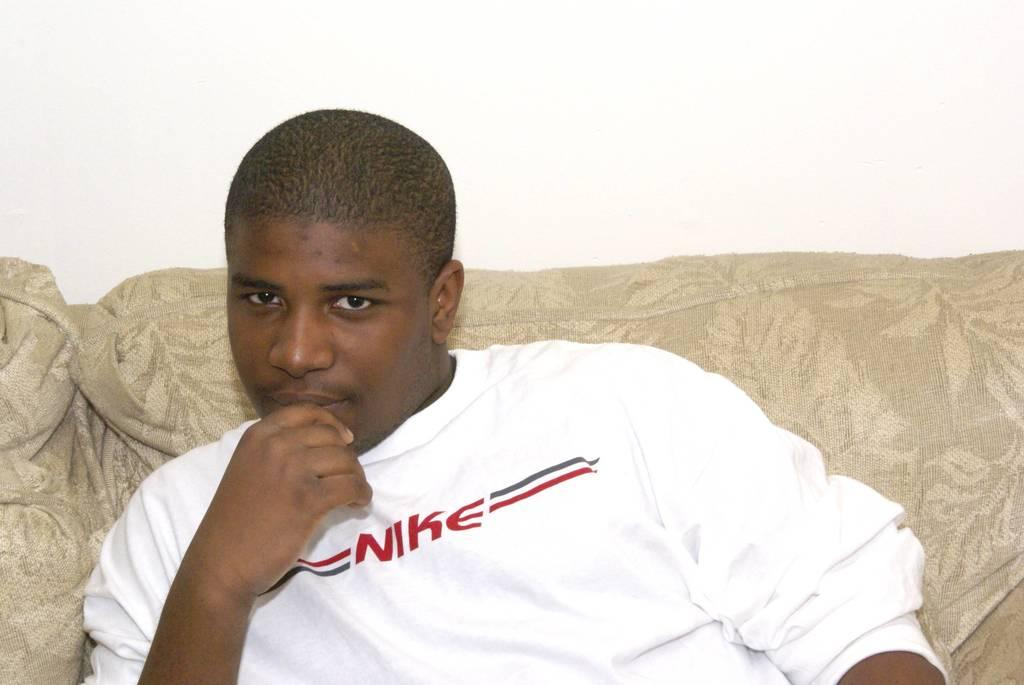<image>
Share a concise interpretation of the image provided. A man sits on a beige couch wearing a Nike shirt. 